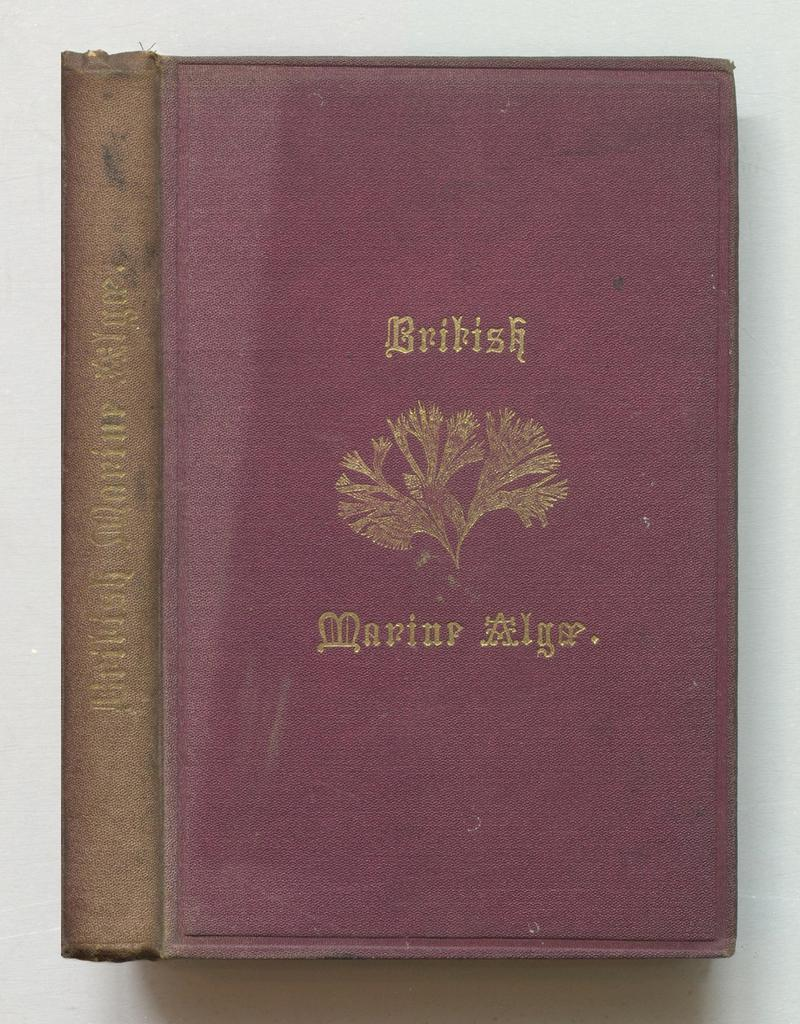<image>
Present a compact description of the photo's key features. British Marine alga book with a tree logo on the front cover. 